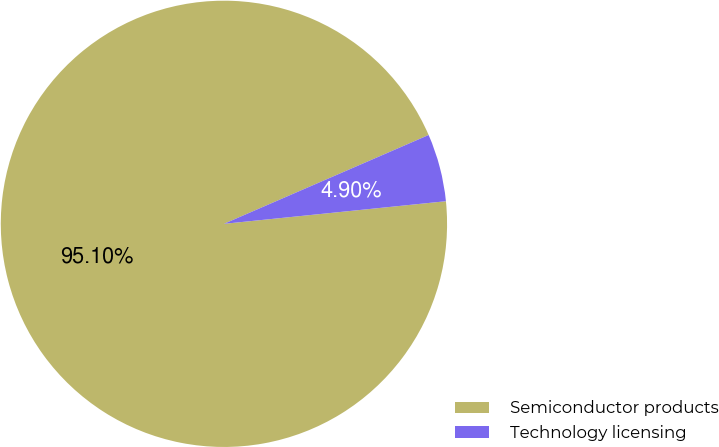Convert chart to OTSL. <chart><loc_0><loc_0><loc_500><loc_500><pie_chart><fcel>Semiconductor products<fcel>Technology licensing<nl><fcel>95.1%<fcel>4.9%<nl></chart> 